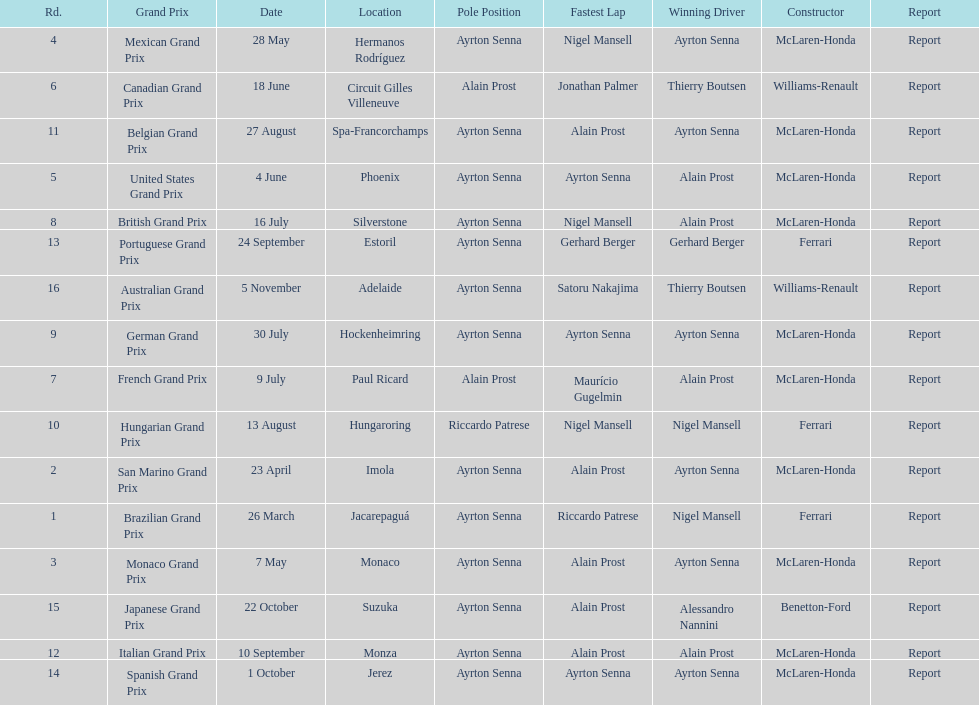What was the only grand prix to be won by benneton-ford? Japanese Grand Prix. 